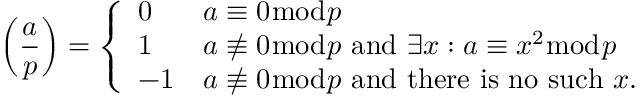<formula> <loc_0><loc_0><loc_500><loc_500>\left ( { \frac { a } { p } } \right ) = { \left \{ \begin{array} { l l } { 0 } & { a \equiv 0 { \bmod { p } } } \\ { 1 } & { a \not \equiv 0 { \bmod { p } } { a n d } \exists x \colon a \equiv x ^ { 2 } { \bmod { p } } } \\ { - 1 } & { a \not \equiv 0 { \bmod { p } } { a n d t h e r e i s n o s u c h } x . } \end{array} }</formula> 